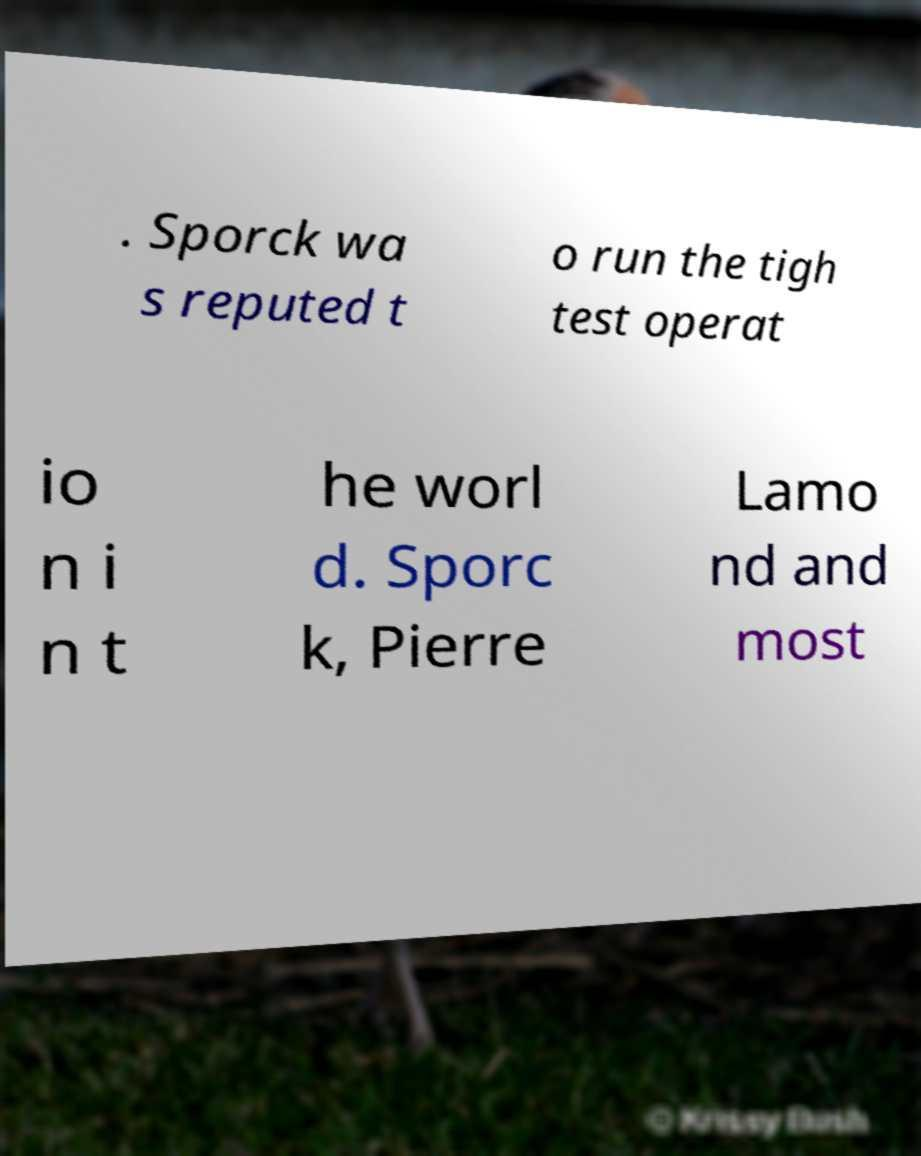Could you assist in decoding the text presented in this image and type it out clearly? . Sporck wa s reputed t o run the tigh test operat io n i n t he worl d. Sporc k, Pierre Lamo nd and most 